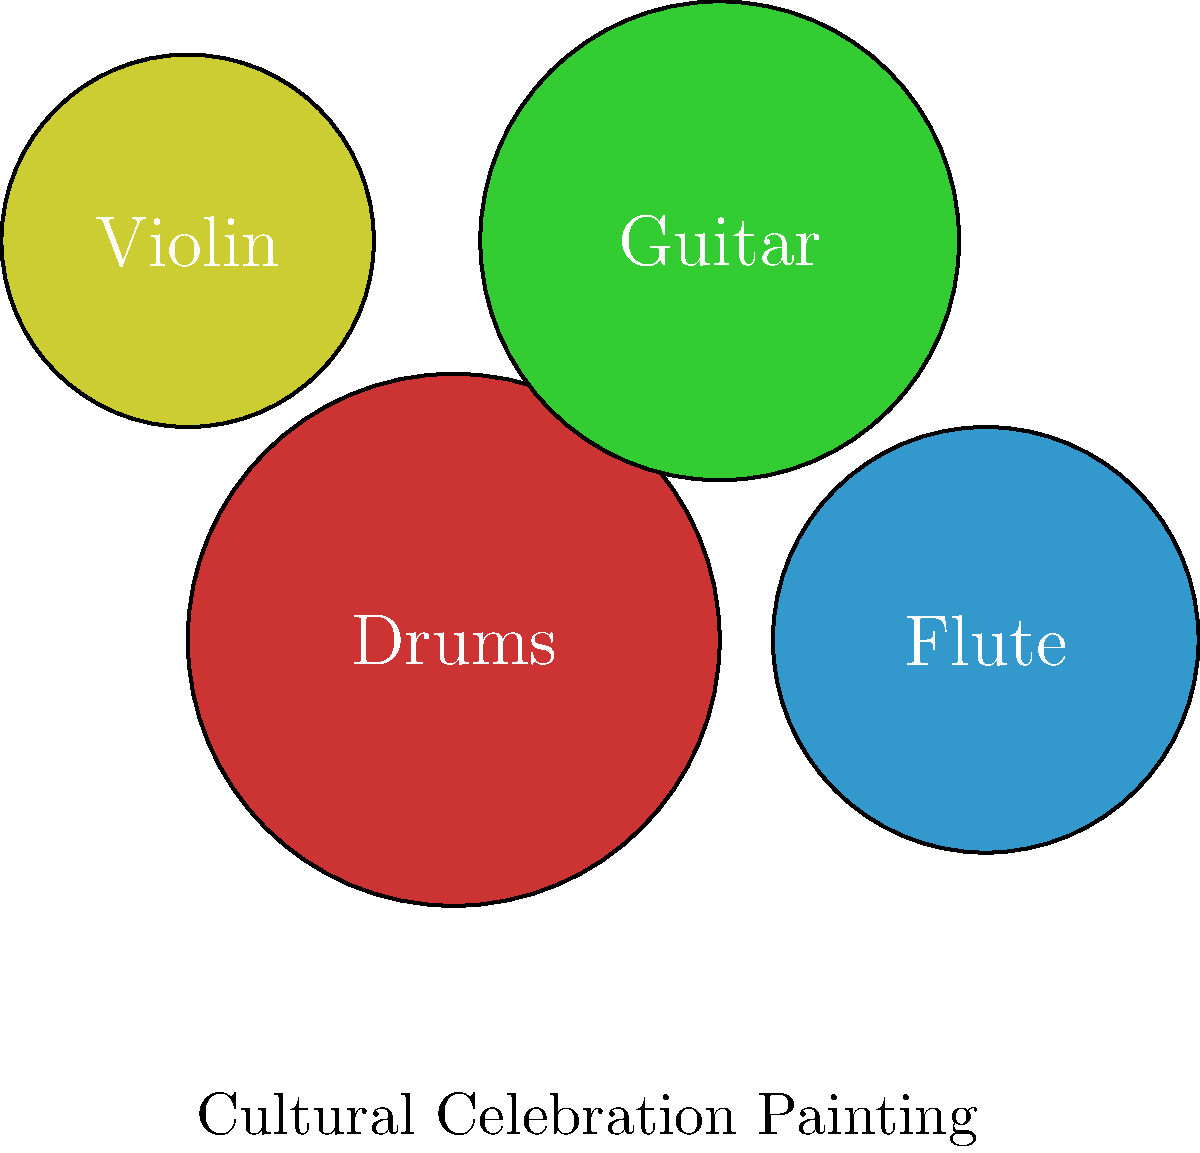In a machine learning model designed to detect and categorize musical instruments in paintings of cultural celebrations, which feature extraction technique would be most effective for distinguishing between the circular shapes of drums and the elongated forms of string instruments like guitars and violins? To effectively distinguish between circular shapes (drums) and elongated forms (guitars, violins) in paintings, we need to consider the following steps:

1. Image preprocessing: Apply techniques like noise reduction and contrast enhancement to improve image quality.

2. Feature extraction: This is the key step for our question. We should use:
   a) Shape descriptors: These can capture the geometric properties of the instruments.
   b) Specifically, we should use Hu Moments, which are invariant to translation, scale, and rotation.

3. Why Hu Moments are effective:
   a) They can distinguish between circular and elongated shapes.
   b) The first Hu Moment ($$M_1$$) is particularly useful:
      - For circular shapes (drums), $$M_1$$ will be closer to 1.
      - For elongated shapes (guitars, violins), $$M_1$$ will be significantly smaller.

4. Additional features to consider:
   a) Edge detection to outline the instruments.
   b) Texture analysis to capture the surface patterns of different instruments.

5. Classification: Use the extracted features to train a classifier (e.g., SVM, Random Forest) to categorize the instruments.

6. Post-processing: Apply techniques like non-maximum suppression to refine the detection results.

By focusing on shape descriptors, particularly Hu Moments, we can effectively distinguish between circular drums and elongated string instruments in cultural celebration paintings.
Answer: Hu Moments 